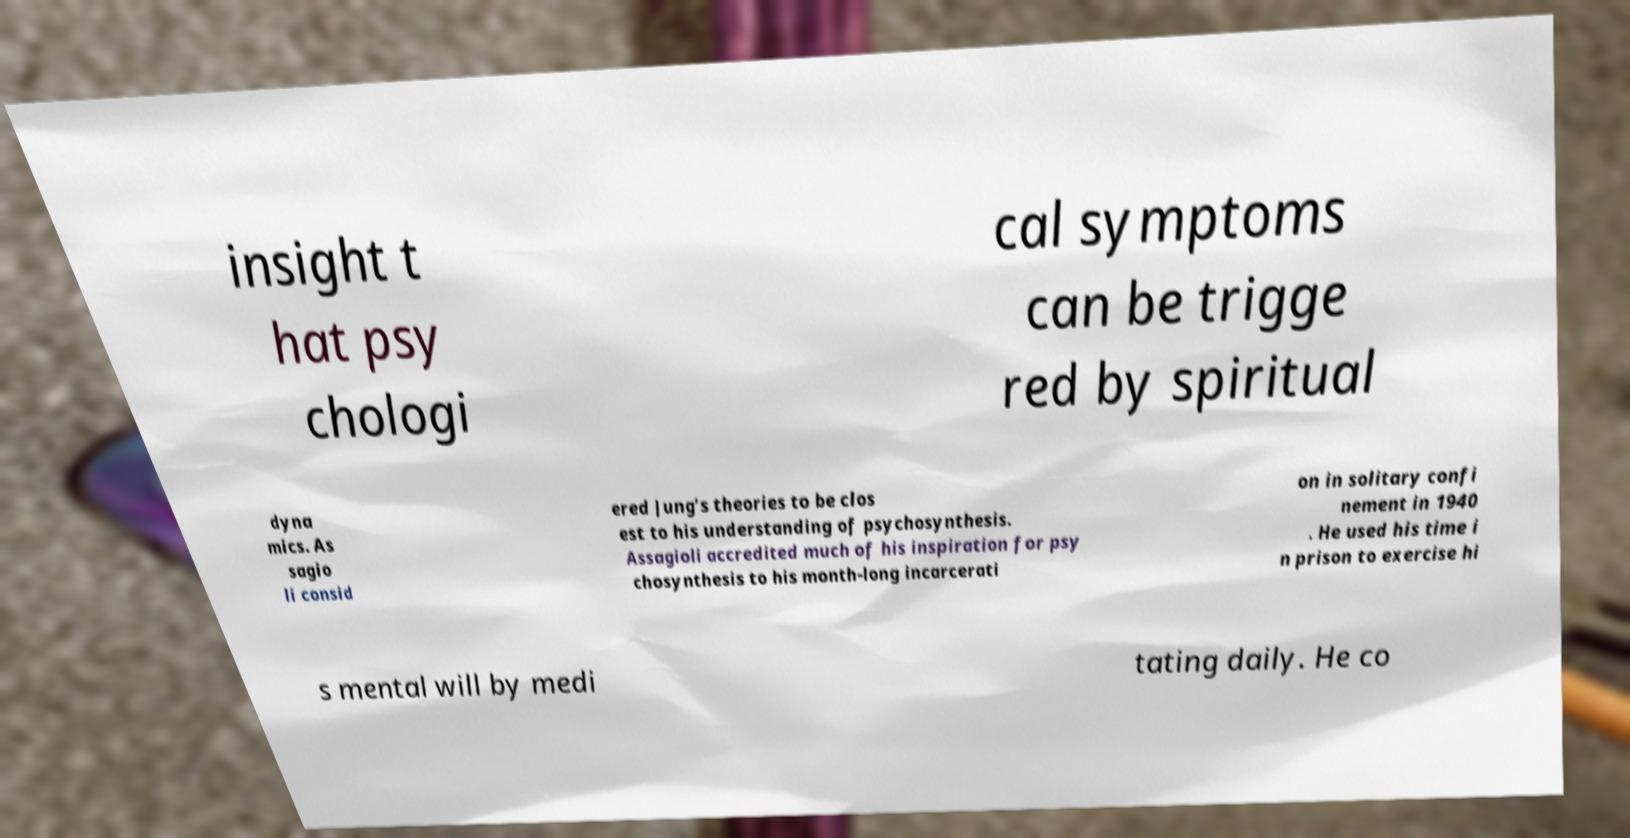Please identify and transcribe the text found in this image. insight t hat psy chologi cal symptoms can be trigge red by spiritual dyna mics. As sagio li consid ered Jung’s theories to be clos est to his understanding of psychosynthesis. Assagioli accredited much of his inspiration for psy chosynthesis to his month-long incarcerati on in solitary confi nement in 1940 . He used his time i n prison to exercise hi s mental will by medi tating daily. He co 